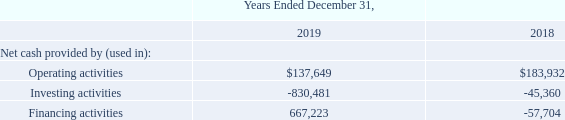Cash Flows
The following table sets forth summary cash flow data for the periods indicated (in thousands).
Cash Flow from Operating Activities
Net cash flows provided by operating activities for the year ended December 31, 2019, were $137.6 million as compared to $183.9 million during the same period in 2018. Net cash provided by operating activities primarily consists of net income adjusted to add back depreciation, amortization, and stock-based compensation. Cash flows provided by operating activities were $46.3 million lower for the year ended December 31, 2019, compared to the same period in 2018, due to the timing of working capital. Our current policy is to use our operating cash flow primarily for funding capital expenditures, lease payments, stock repurchases, and acquisitions.
Cash Flow from Investing Activities
During the year ended December 31, 2019, we paid $753.9 million, net of $0.1 million in cash acquired, to acquire Speedpay. We also used cash of $18.5 million to invest in a payment technology and services company in India and $7.0 million to acquire the technology assets of RevChip, LLC and TranSend Integrated Technologies Inc. In addition, we used cash of $48.0 million to purchase software, property and equipment, as compared to $43.9 million during the same period in 2018.
Cash Flow from Financing Activities
Net cash flows provided by financing activities for the year ended December 31, 2019, were $667.2 million, as compared to net cash flows used by financing activities of $57.7 million during the same period in 2018. During 2019, we received proceeds of $500.0 million from our Delayed Draw Term Loan and $280.0 million from our Revolving Credit Facility to fund our purchase of Speedpay and stock repurchases, and we repaid $28.9 million on the Initial Term Loan and $41.0 million on the Revolving Credit Facility. In addition, we received proceeds of $16.6 million from the exercise of stock options and the issuance of common stock under our 2017 Employee Stock Purchase Plan, as amended, and used $4.0 million for the repurchase of stock-based compensation awards for tax withholdings. During 2019, we also used $35.6 million to repurchase common stock. During 2018, we received proceeds of $400.0 million from the issuance of the 2026 Notes. We used $300.0 million of the proceeds to redeem, in full, our outstanding 6.375% Senior Notes due 2020 and repaid $109.3 million on the Initial Term Loan. In addition, during 2018, we received proceeds of $22.8 million from the exercise of stock options and the issuance of common stock under our 2017 Employee Stock Purchase Plan, as amended, and used $2.6 million for the repurchase of restricted share awards ("RSAs") for tax withholdings. During 2018, we also used $54.5 million to repurchase common stock.
What was the net cash from operating activities in 2018?
Answer scale should be: thousand. $183,932. What was the net cash from operating activities in 2019?
Answer scale should be: thousand. $137,649. What was the net cash used in investing activities in 2019?
Answer scale should be: thousand. -830,481. What was the change in net cash from operating activities between 2018 and 2019?
Answer scale should be: thousand. $183,932-$137,649
Answer: 46283. What was the change in net cash used in investing activities between 2018 and 2019?
Answer scale should be: thousand. -830,481+45,360
Answer: -785121. What was the percentage change in net cash from financing activities between 2018 and 2019?
Answer scale should be: percent. (667,223+57,704)/57,704
Answer: 1256.29. 